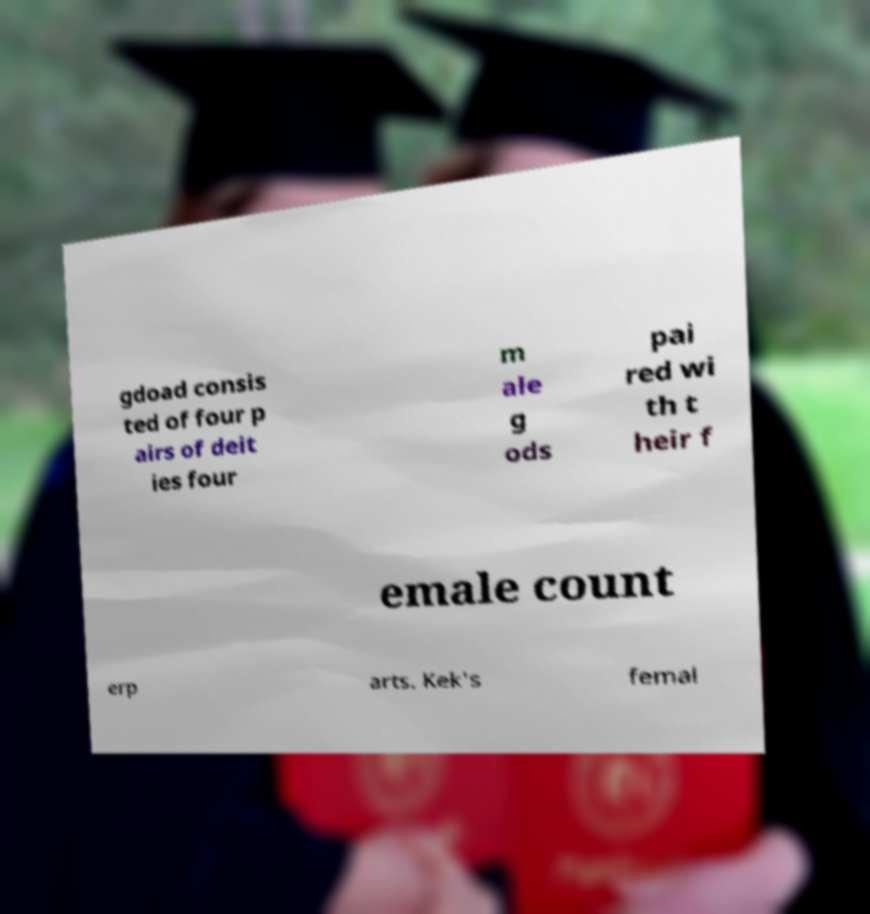Could you extract and type out the text from this image? gdoad consis ted of four p airs of deit ies four m ale g ods pai red wi th t heir f emale count erp arts. Kek's femal 